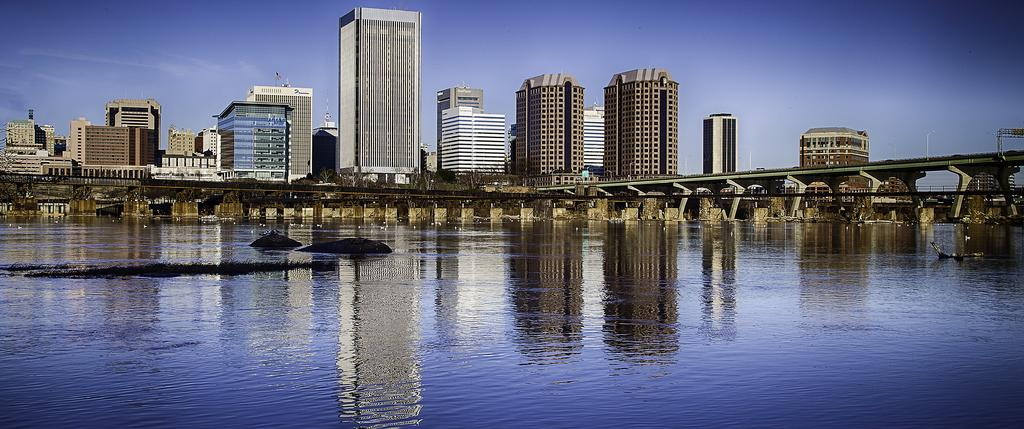What body of water is present in the image? There is a lake in the image. What structure can be seen on the lake? There is a bridge on the lake. What types of structures are located around the lake? There are buildings and houses around the lake. Can you describe any other features or objects around the lake? There are other unspecified things around the lake. What type of corn is growing on the bridge in the image? There is no corn present in the image, and the bridge does not have any plants growing on it. 